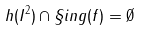<formula> <loc_0><loc_0><loc_500><loc_500>h ( { I ^ { 2 } } ) \cap \S i n g ( f ) = \emptyset</formula> 